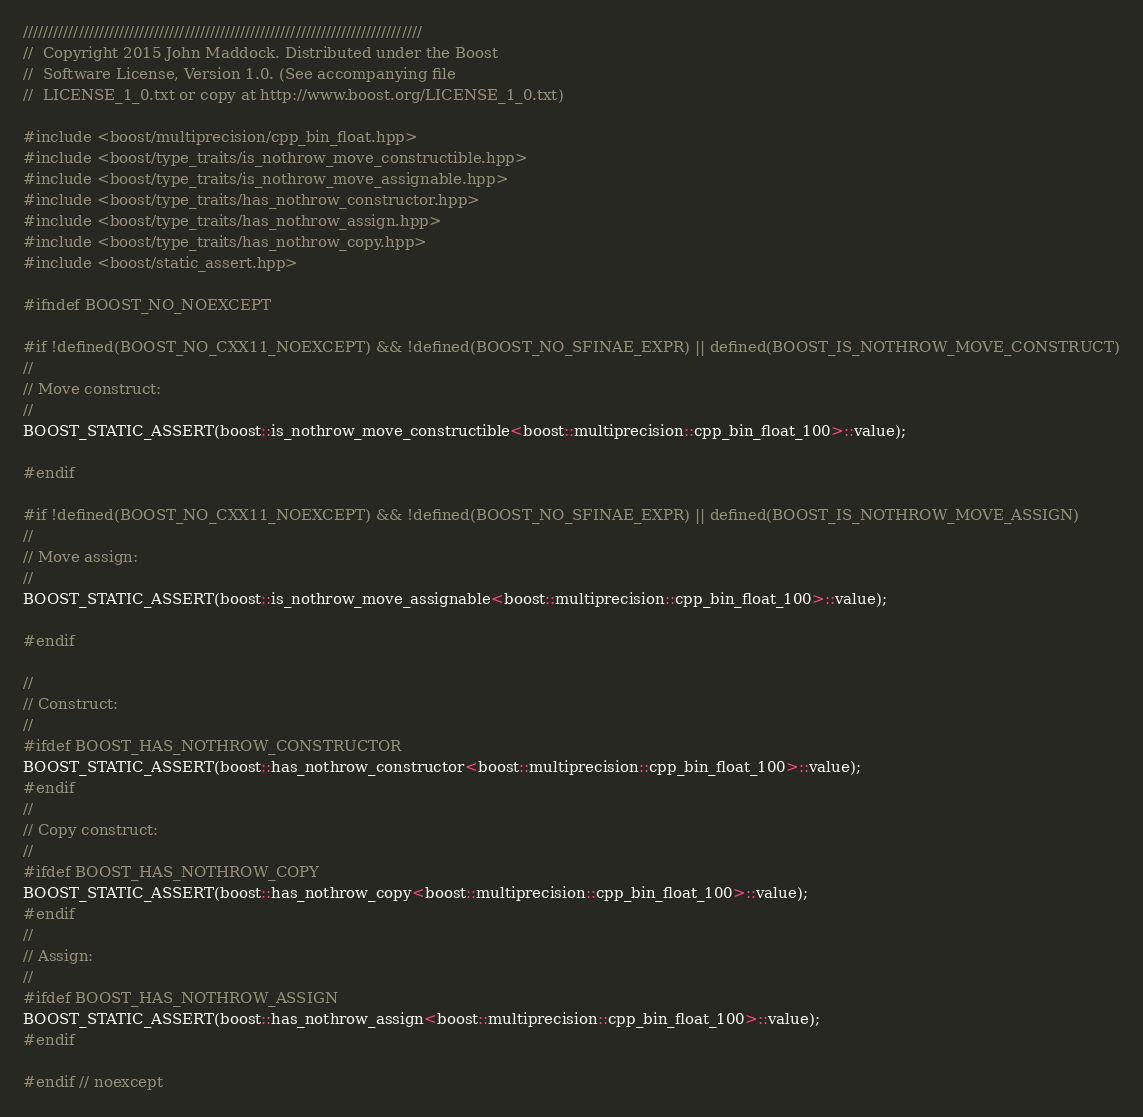<code> <loc_0><loc_0><loc_500><loc_500><_C++_>///////////////////////////////////////////////////////////////////////////////
//  Copyright 2015 John Maddock. Distributed under the Boost
//  Software License, Version 1.0. (See accompanying file
//  LICENSE_1_0.txt or copy at http://www.boost.org/LICENSE_1_0.txt)

#include <boost/multiprecision/cpp_bin_float.hpp>
#include <boost/type_traits/is_nothrow_move_constructible.hpp>
#include <boost/type_traits/is_nothrow_move_assignable.hpp>
#include <boost/type_traits/has_nothrow_constructor.hpp>
#include <boost/type_traits/has_nothrow_assign.hpp>
#include <boost/type_traits/has_nothrow_copy.hpp>
#include <boost/static_assert.hpp>

#ifndef BOOST_NO_NOEXCEPT

#if !defined(BOOST_NO_CXX11_NOEXCEPT) && !defined(BOOST_NO_SFINAE_EXPR) || defined(BOOST_IS_NOTHROW_MOVE_CONSTRUCT)
//
// Move construct:
//
BOOST_STATIC_ASSERT(boost::is_nothrow_move_constructible<boost::multiprecision::cpp_bin_float_100>::value);

#endif

#if !defined(BOOST_NO_CXX11_NOEXCEPT) && !defined(BOOST_NO_SFINAE_EXPR) || defined(BOOST_IS_NOTHROW_MOVE_ASSIGN)
//
// Move assign:
//
BOOST_STATIC_ASSERT(boost::is_nothrow_move_assignable<boost::multiprecision::cpp_bin_float_100>::value);

#endif

//
// Construct:
//
#ifdef BOOST_HAS_NOTHROW_CONSTRUCTOR
BOOST_STATIC_ASSERT(boost::has_nothrow_constructor<boost::multiprecision::cpp_bin_float_100>::value);
#endif
//
// Copy construct:
//
#ifdef BOOST_HAS_NOTHROW_COPY
BOOST_STATIC_ASSERT(boost::has_nothrow_copy<boost::multiprecision::cpp_bin_float_100>::value);
#endif
//
// Assign:
//
#ifdef BOOST_HAS_NOTHROW_ASSIGN
BOOST_STATIC_ASSERT(boost::has_nothrow_assign<boost::multiprecision::cpp_bin_float_100>::value);
#endif

#endif // noexcept


</code> 